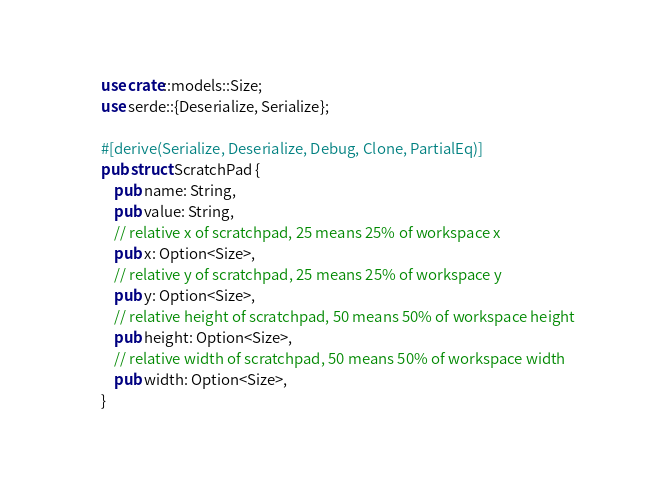<code> <loc_0><loc_0><loc_500><loc_500><_Rust_>use crate::models::Size;
use serde::{Deserialize, Serialize};

#[derive(Serialize, Deserialize, Debug, Clone, PartialEq)]
pub struct ScratchPad {
    pub name: String,
    pub value: String,
    // relative x of scratchpad, 25 means 25% of workspace x
    pub x: Option<Size>,
    // relative y of scratchpad, 25 means 25% of workspace y
    pub y: Option<Size>,
    // relative height of scratchpad, 50 means 50% of workspace height
    pub height: Option<Size>,
    // relative width of scratchpad, 50 means 50% of workspace width
    pub width: Option<Size>,
}
</code> 